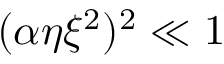Convert formula to latex. <formula><loc_0><loc_0><loc_500><loc_500>( \alpha \eta \xi ^ { 2 } ) ^ { 2 } \ll 1</formula> 